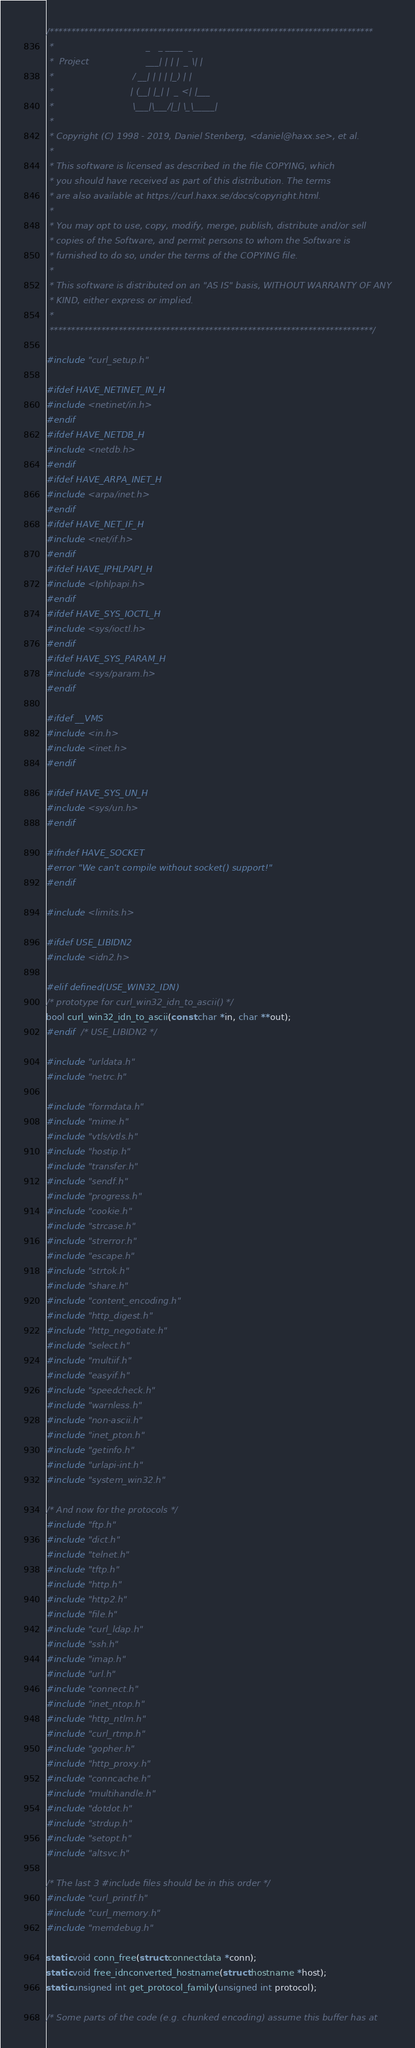<code> <loc_0><loc_0><loc_500><loc_500><_C_>/***************************************************************************
 *                                  _   _ ____  _
 *  Project                     ___| | | |  _ \| |
 *                             / __| | | | |_) | |
 *                            | (__| |_| |  _ <| |___
 *                             \___|\___/|_| \_\_____|
 *
 * Copyright (C) 1998 - 2019, Daniel Stenberg, <daniel@haxx.se>, et al.
 *
 * This software is licensed as described in the file COPYING, which
 * you should have received as part of this distribution. The terms
 * are also available at https://curl.haxx.se/docs/copyright.html.
 *
 * You may opt to use, copy, modify, merge, publish, distribute and/or sell
 * copies of the Software, and permit persons to whom the Software is
 * furnished to do so, under the terms of the COPYING file.
 *
 * This software is distributed on an "AS IS" basis, WITHOUT WARRANTY OF ANY
 * KIND, either express or implied.
 *
 ***************************************************************************/

#include "curl_setup.h"

#ifdef HAVE_NETINET_IN_H
#include <netinet/in.h>
#endif
#ifdef HAVE_NETDB_H
#include <netdb.h>
#endif
#ifdef HAVE_ARPA_INET_H
#include <arpa/inet.h>
#endif
#ifdef HAVE_NET_IF_H
#include <net/if.h>
#endif
#ifdef HAVE_IPHLPAPI_H
#include <Iphlpapi.h>
#endif
#ifdef HAVE_SYS_IOCTL_H
#include <sys/ioctl.h>
#endif
#ifdef HAVE_SYS_PARAM_H
#include <sys/param.h>
#endif

#ifdef __VMS
#include <in.h>
#include <inet.h>
#endif

#ifdef HAVE_SYS_UN_H
#include <sys/un.h>
#endif

#ifndef HAVE_SOCKET
#error "We can't compile without socket() support!"
#endif

#include <limits.h>

#ifdef USE_LIBIDN2
#include <idn2.h>

#elif defined(USE_WIN32_IDN)
/* prototype for curl_win32_idn_to_ascii() */
bool curl_win32_idn_to_ascii(const char *in, char **out);
#endif  /* USE_LIBIDN2 */

#include "urldata.h"
#include "netrc.h"

#include "formdata.h"
#include "mime.h"
#include "vtls/vtls.h"
#include "hostip.h"
#include "transfer.h"
#include "sendf.h"
#include "progress.h"
#include "cookie.h"
#include "strcase.h"
#include "strerror.h"
#include "escape.h"
#include "strtok.h"
#include "share.h"
#include "content_encoding.h"
#include "http_digest.h"
#include "http_negotiate.h"
#include "select.h"
#include "multiif.h"
#include "easyif.h"
#include "speedcheck.h"
#include "warnless.h"
#include "non-ascii.h"
#include "inet_pton.h"
#include "getinfo.h"
#include "urlapi-int.h"
#include "system_win32.h"

/* And now for the protocols */
#include "ftp.h"
#include "dict.h"
#include "telnet.h"
#include "tftp.h"
#include "http.h"
#include "http2.h"
#include "file.h"
#include "curl_ldap.h"
#include "ssh.h"
#include "imap.h"
#include "url.h"
#include "connect.h"
#include "inet_ntop.h"
#include "http_ntlm.h"
#include "curl_rtmp.h"
#include "gopher.h"
#include "http_proxy.h"
#include "conncache.h"
#include "multihandle.h"
#include "dotdot.h"
#include "strdup.h"
#include "setopt.h"
#include "altsvc.h"

/* The last 3 #include files should be in this order */
#include "curl_printf.h"
#include "curl_memory.h"
#include "memdebug.h"

static void conn_free(struct connectdata *conn);
static void free_idnconverted_hostname(struct hostname *host);
static unsigned int get_protocol_family(unsigned int protocol);

/* Some parts of the code (e.g. chunked encoding) assume this buffer has at</code> 